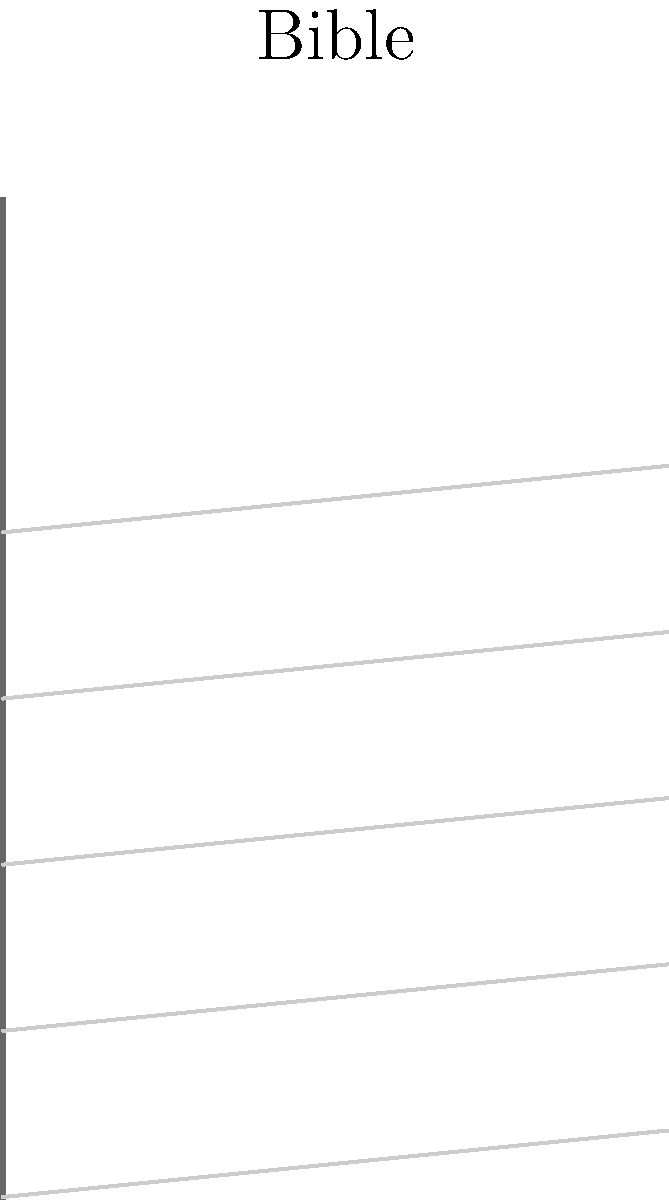Consider the topological structure of a Bible's binding and its pages. If we represent the Bible's binding as a line segment and each page as a curve attached to this segment, what topological shape does this structure most closely resemble? To answer this question, let's consider the topological properties of the Bible's structure step-by-step:

1. The binding of the Bible is represented by a single line segment. In topological terms, this is a 1-dimensional object.

2. Each page of the Bible is attached to this binding along one edge. Topologically, we can think of each page as a 2-dimensional surface.

3. As we move from one page to the next, we're essentially rotating around the binding. This creates a fan-like structure.

4. If we consider the Bible when it's fully opened, with pages fanned out on both sides of the binding, we see that it forms a circular shape around the central binding.

5. In topology, there's a shape that matches this description: the cone. A cone is formed by taking a circular base and connecting every point on its circumference to a single point (the apex) not on the base.

6. In our Bible analogy:
   - The binding represents the apex of the cone.
   - The outer edges of the pages, when the Bible is fully opened, represent the circular base of the cone.
   - Each page represents a line from a point on the circular base to the apex.

7. While a physical Bible doesn't form a perfect cone (as the pages are typically rectangular rather than triangular), topologically, the structure is equivalent to a cone.

Therefore, the topological shape that most closely resembles the structure of a Bible's binding and its pages is a cone.
Answer: Cone 